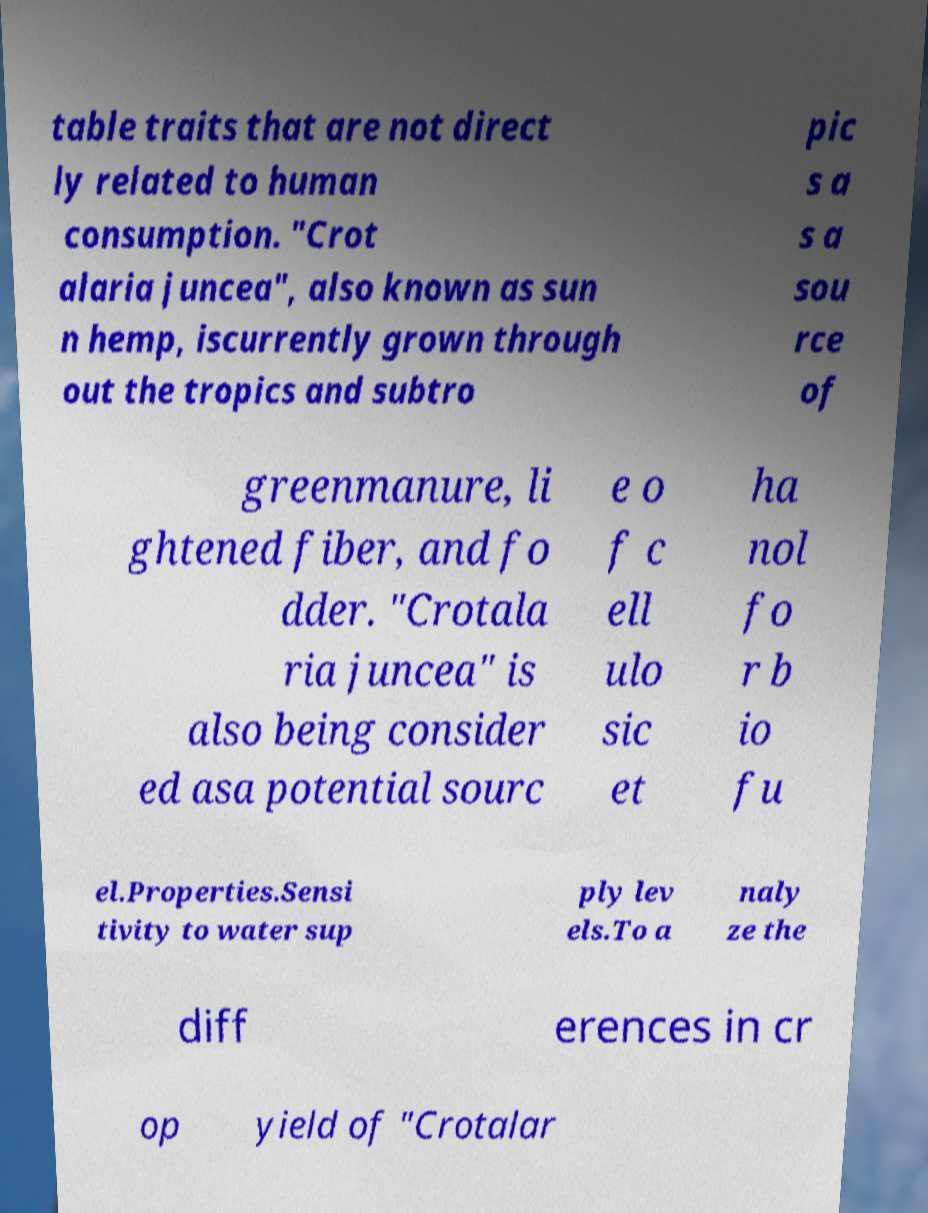Please read and relay the text visible in this image. What does it say? table traits that are not direct ly related to human consumption. "Crot alaria juncea", also known as sun n hemp, iscurrently grown through out the tropics and subtro pic s a s a sou rce of greenmanure, li ghtened fiber, and fo dder. "Crotala ria juncea" is also being consider ed asa potential sourc e o f c ell ulo sic et ha nol fo r b io fu el.Properties.Sensi tivity to water sup ply lev els.To a naly ze the diff erences in cr op yield of "Crotalar 